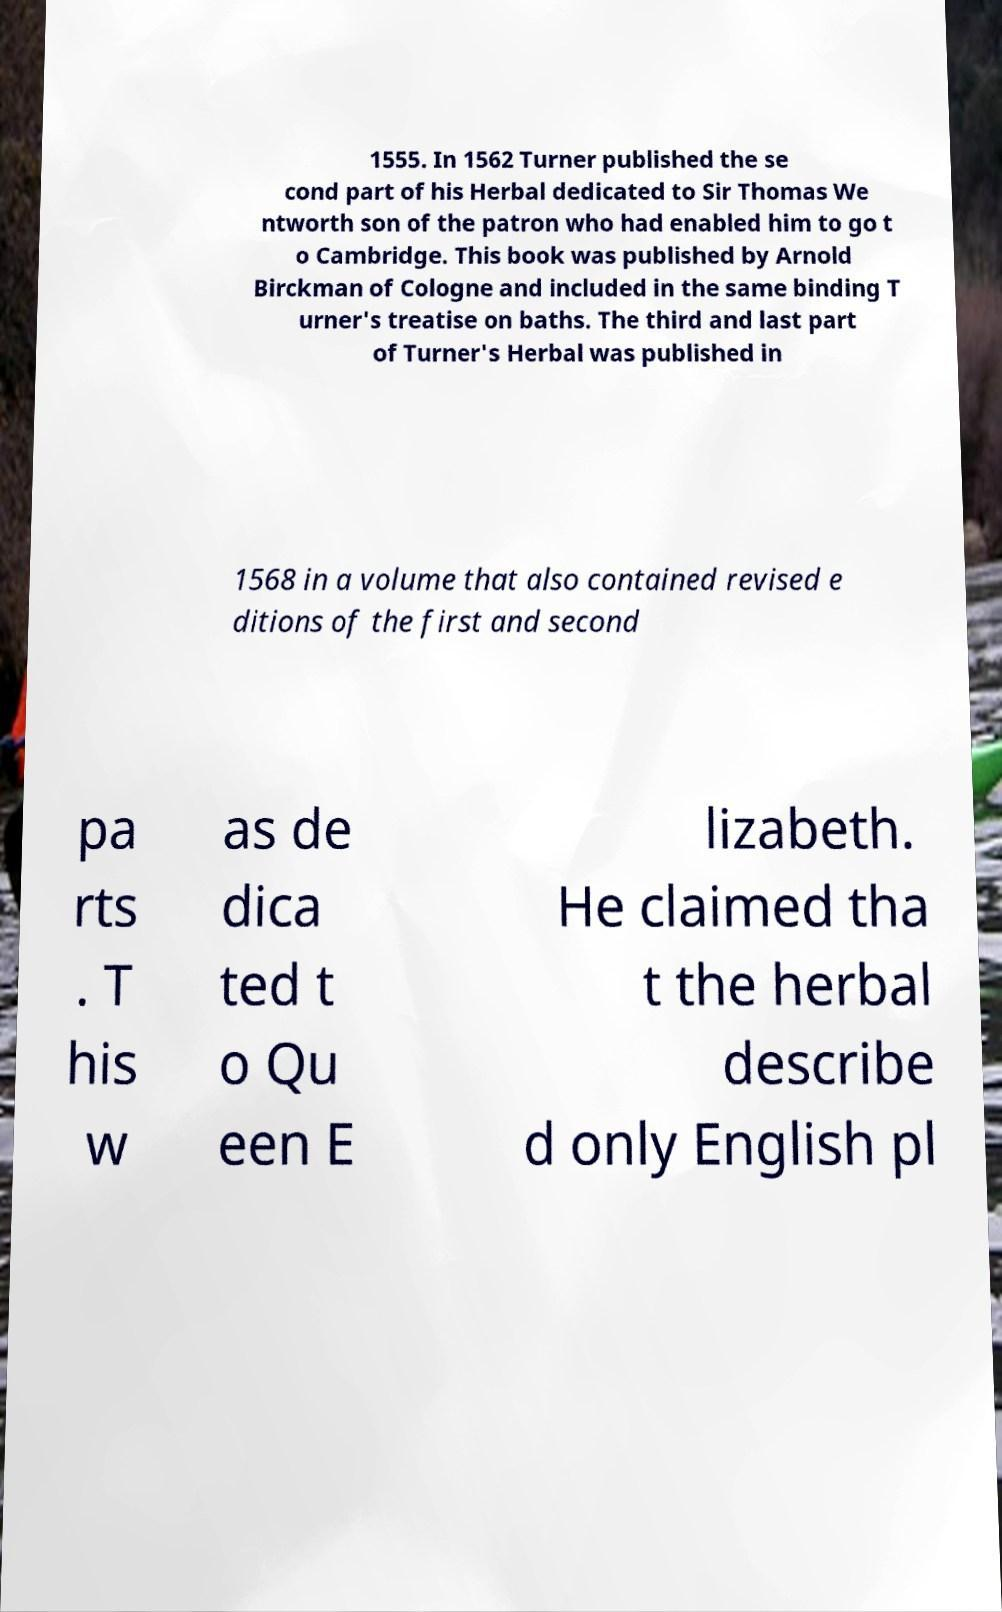Please read and relay the text visible in this image. What does it say? 1555. In 1562 Turner published the se cond part of his Herbal dedicated to Sir Thomas We ntworth son of the patron who had enabled him to go t o Cambridge. This book was published by Arnold Birckman of Cologne and included in the same binding T urner's treatise on baths. The third and last part of Turner's Herbal was published in 1568 in a volume that also contained revised e ditions of the first and second pa rts . T his w as de dica ted t o Qu een E lizabeth. He claimed tha t the herbal describe d only English pl 